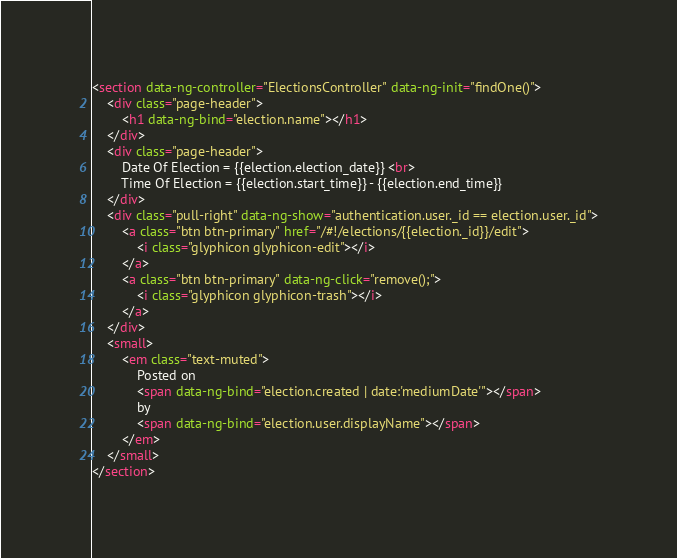Convert code to text. <code><loc_0><loc_0><loc_500><loc_500><_HTML_><section data-ng-controller="ElectionsController" data-ng-init="findOne()">
	<div class="page-header">
		<h1 data-ng-bind="election.name"></h1>
	</div>
	<div class="page-header">
		Date Of Election = {{election.election_date}} <br>
		Time Of Election = {{election.start_time}} - {{election.end_time}}
	</div>
	<div class="pull-right" data-ng-show="authentication.user._id == election.user._id">
		<a class="btn btn-primary" href="/#!/elections/{{election._id}}/edit">
			<i class="glyphicon glyphicon-edit"></i>
		</a>
		<a class="btn btn-primary" data-ng-click="remove();">
			<i class="glyphicon glyphicon-trash"></i>
		</a>
	</div>
	<small>
		<em class="text-muted">
			Posted on
			<span data-ng-bind="election.created | date:'mediumDate'"></span>
			by
			<span data-ng-bind="election.user.displayName"></span>
		</em>
	</small>
</section></code> 